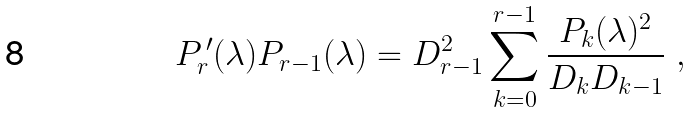Convert formula to latex. <formula><loc_0><loc_0><loc_500><loc_500>P _ { r } ^ { \, \prime } ( \lambda ) P _ { r - 1 } ( \lambda ) = D _ { r - 1 } ^ { 2 } \sum _ { k = 0 } ^ { r - 1 } \frac { P _ { k } ( \lambda ) ^ { 2 } } { D _ { k } D _ { k - 1 } } \ ,</formula> 